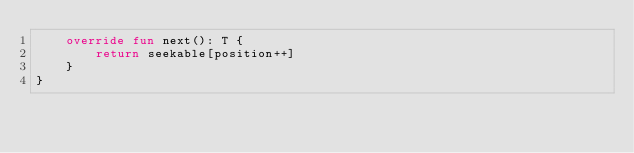<code> <loc_0><loc_0><loc_500><loc_500><_Kotlin_>    override fun next(): T {
        return seekable[position++]
    }
}
</code> 